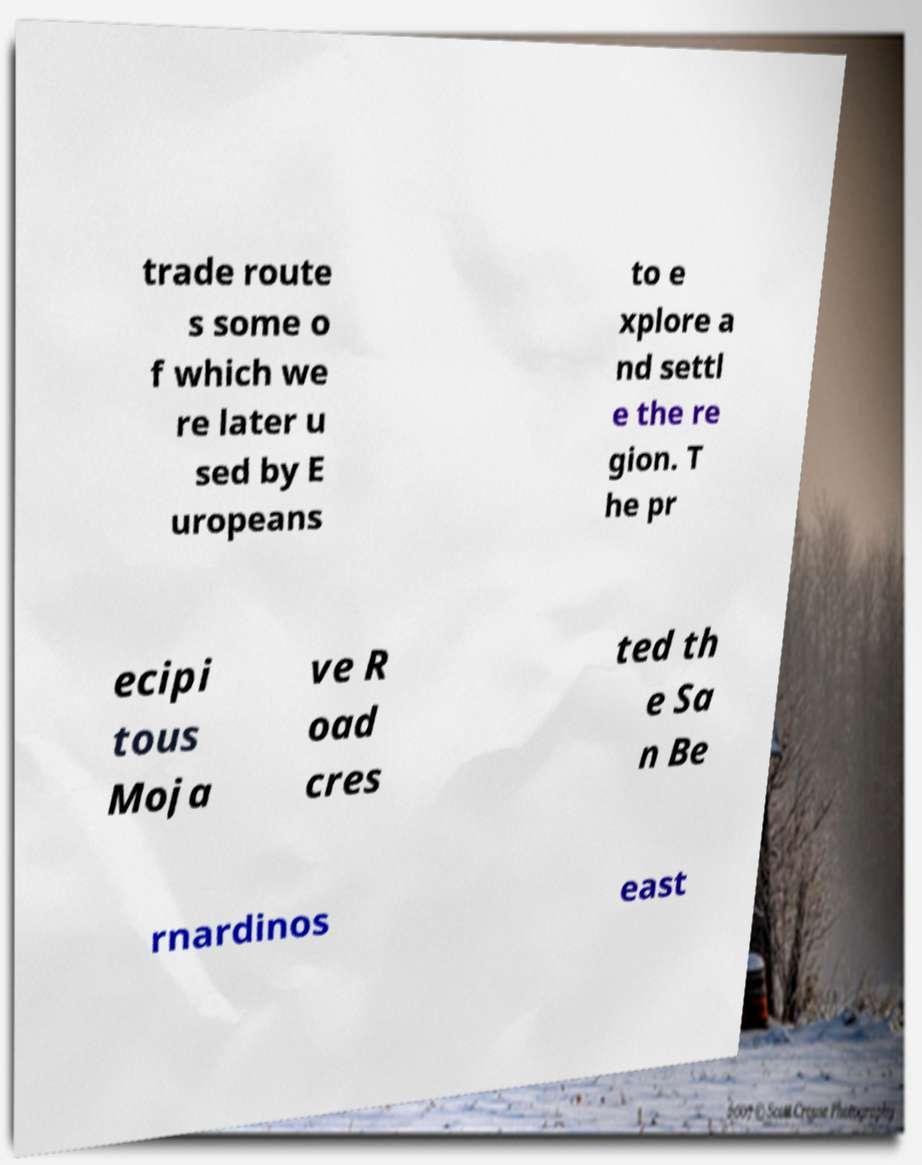What messages or text are displayed in this image? I need them in a readable, typed format. trade route s some o f which we re later u sed by E uropeans to e xplore a nd settl e the re gion. T he pr ecipi tous Moja ve R oad cres ted th e Sa n Be rnardinos east 